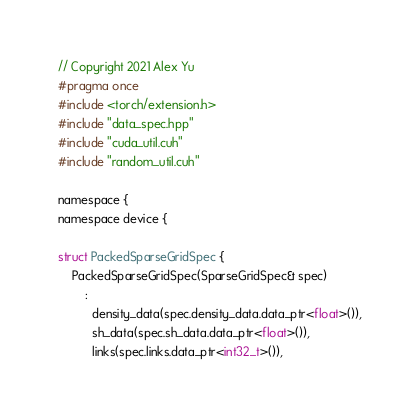<code> <loc_0><loc_0><loc_500><loc_500><_Cuda_>// Copyright 2021 Alex Yu
#pragma once
#include <torch/extension.h>
#include "data_spec.hpp"
#include "cuda_util.cuh"
#include "random_util.cuh"

namespace {
namespace device {

struct PackedSparseGridSpec {
    PackedSparseGridSpec(SparseGridSpec& spec)
        :
          density_data(spec.density_data.data_ptr<float>()),
          sh_data(spec.sh_data.data_ptr<float>()),
          links(spec.links.data_ptr<int32_t>()),</code> 